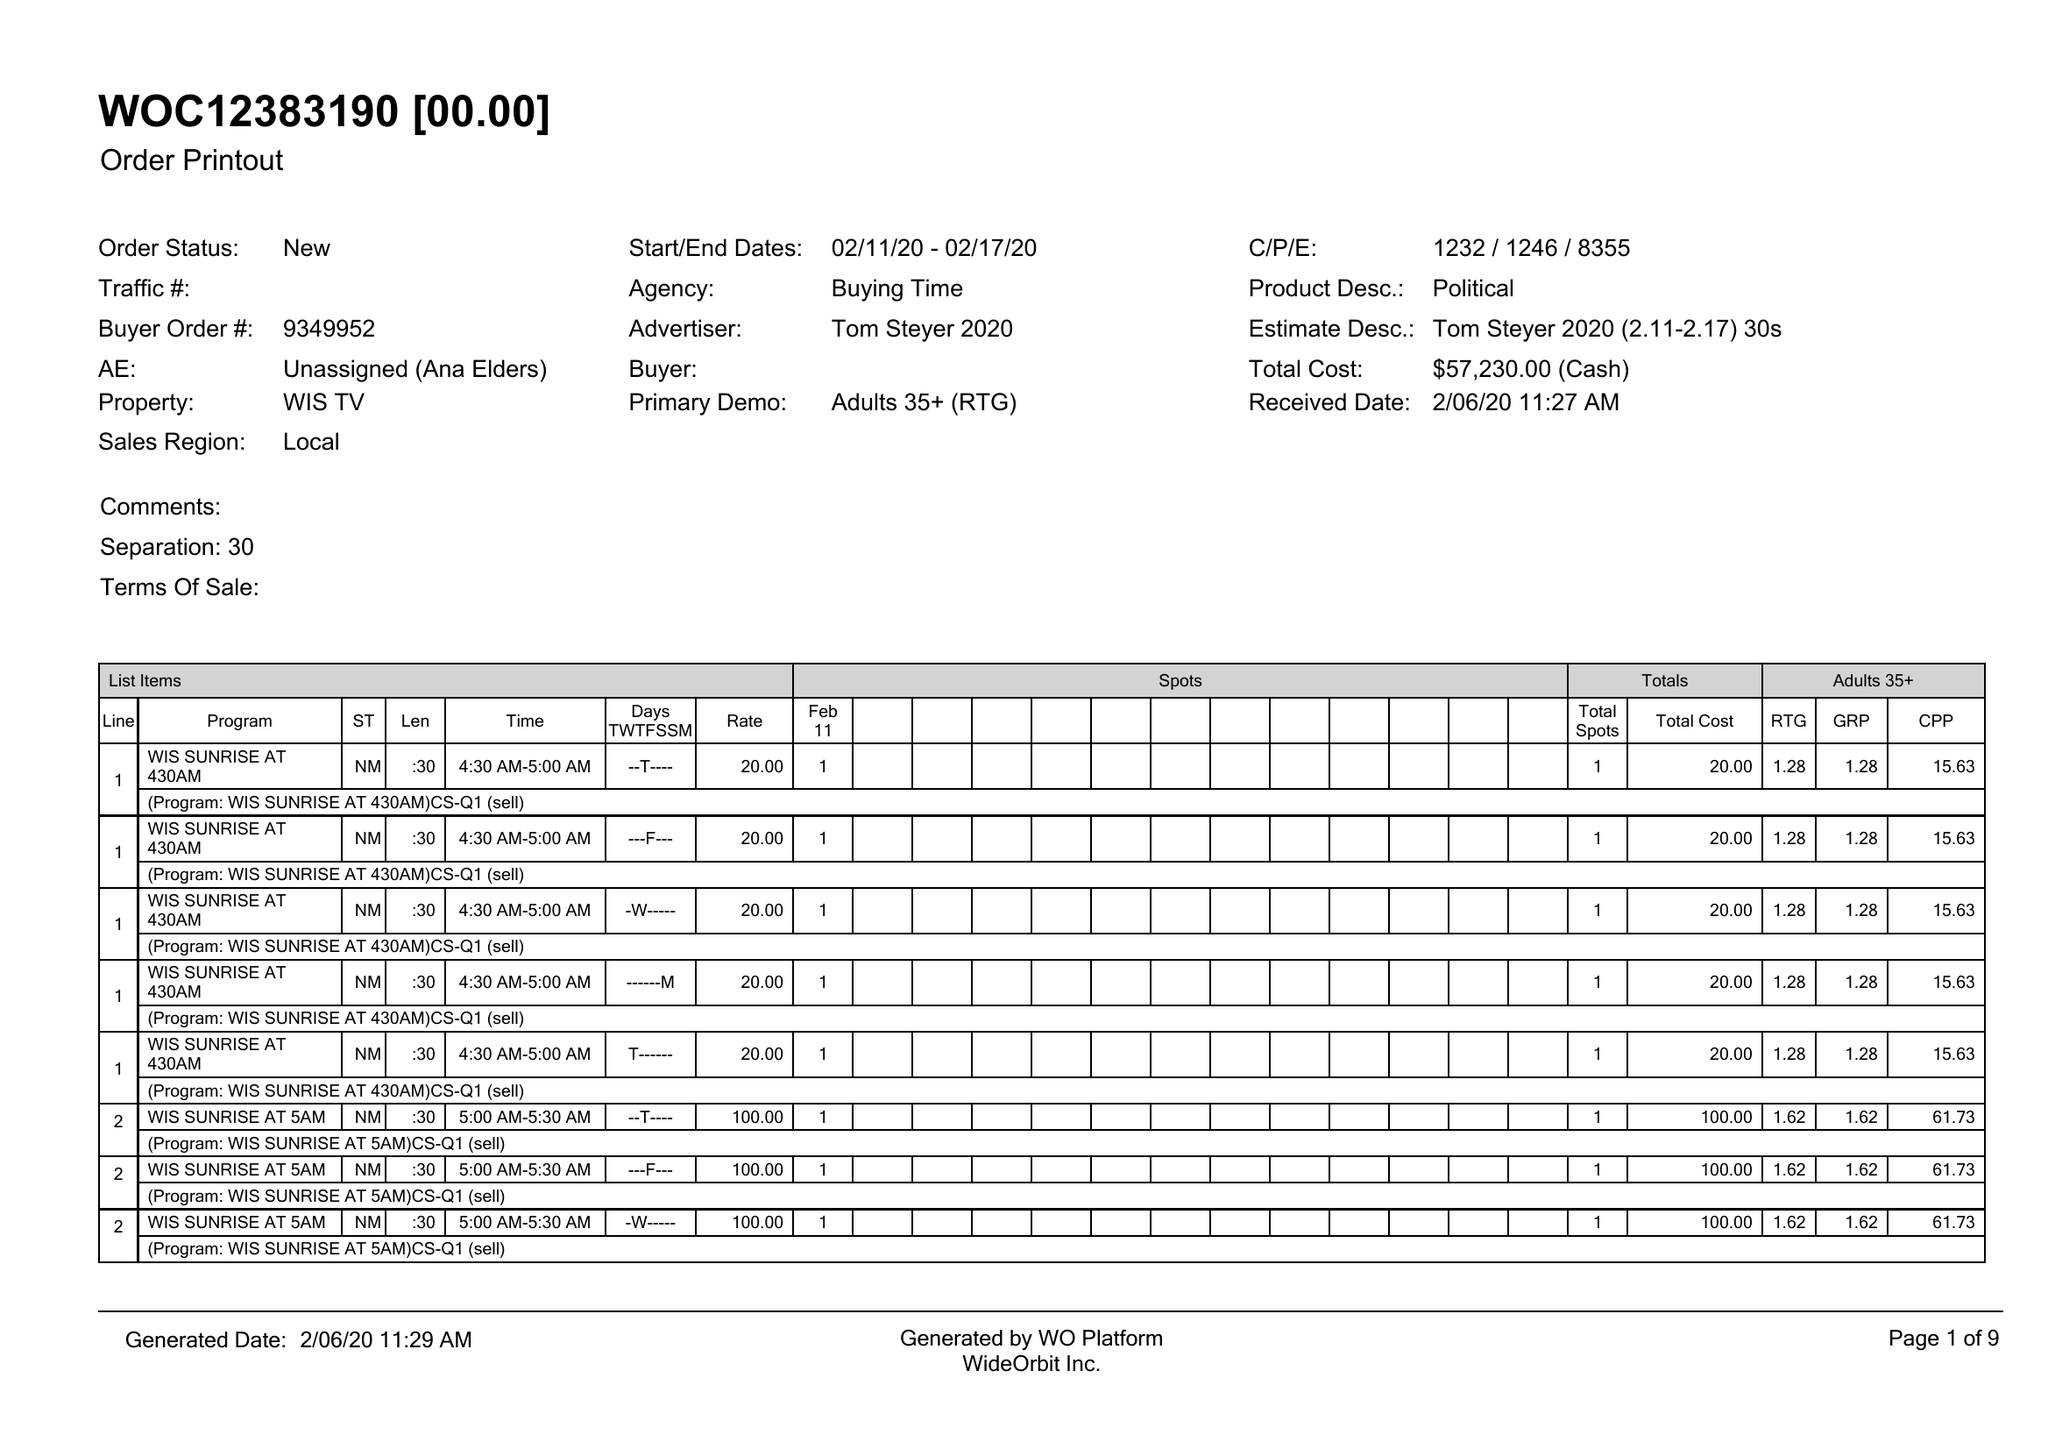What is the value for the flight_to?
Answer the question using a single word or phrase. 02/17/20 